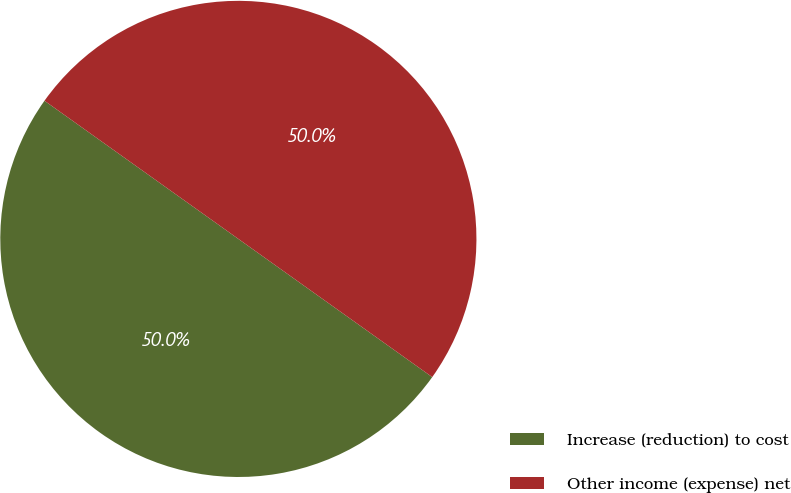Convert chart to OTSL. <chart><loc_0><loc_0><loc_500><loc_500><pie_chart><fcel>Increase (reduction) to cost<fcel>Other income (expense) net<nl><fcel>50.0%<fcel>50.0%<nl></chart> 